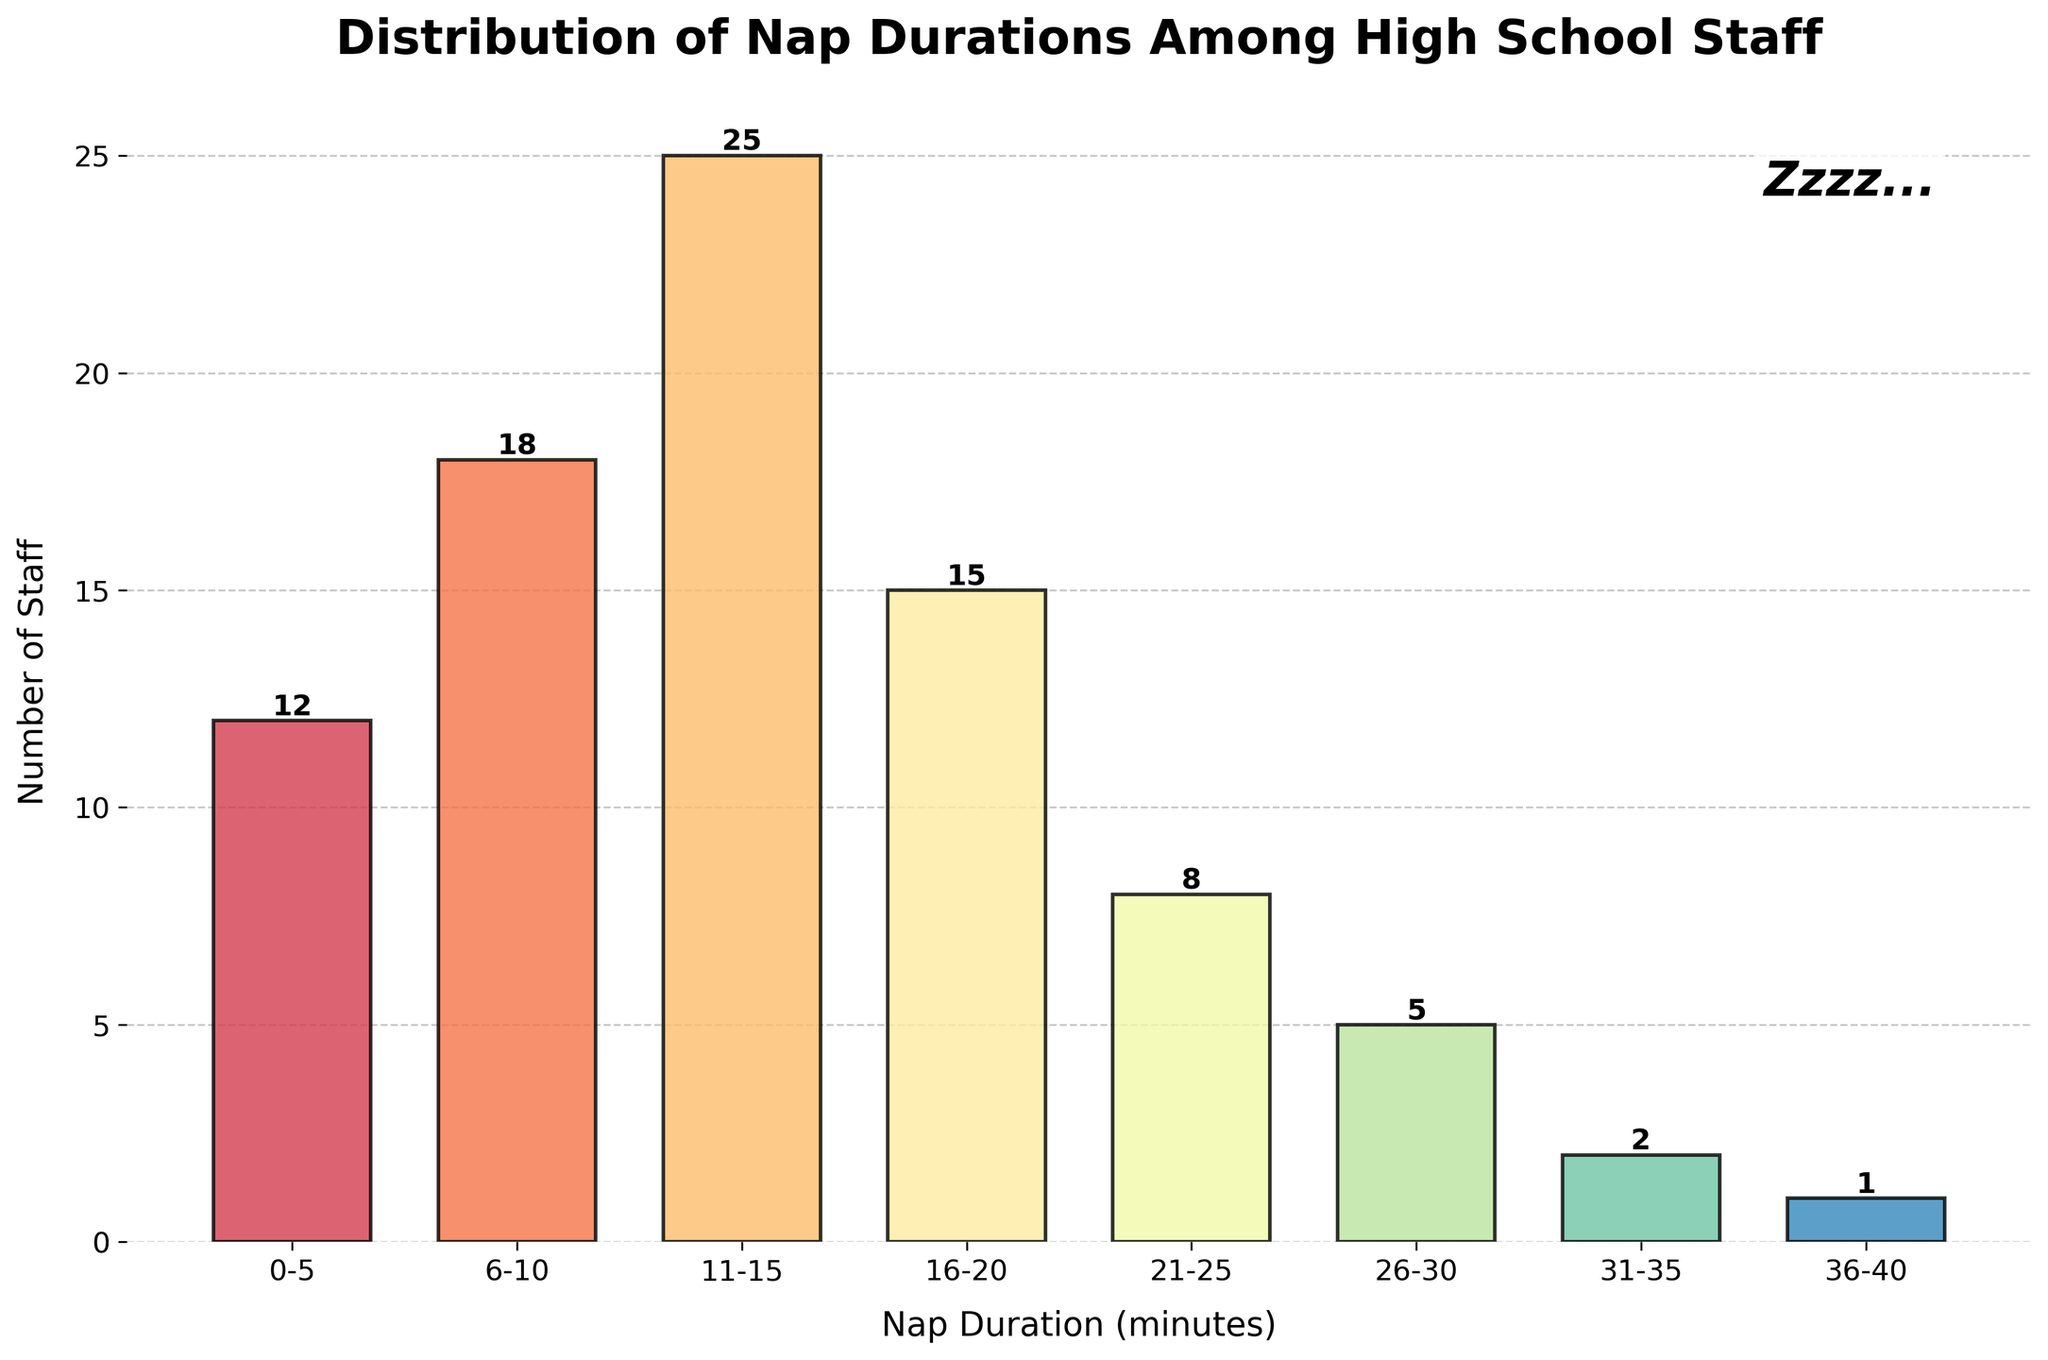How many staff members typically nap for more than 20 minutes? To find the total number of staff napping for more than 20 minutes, sum the counts for the intervals: 21-25 (8), 26-30 (5), 31-35 (2), and 36-40 (1). So, 8 + 5 + 2 + 1 = 16.
Answer: 16 What is the most common nap duration among the staff? The bar with the highest count represents the most common nap duration. The interval 11-15 minutes has the highest count at 25 staff members.
Answer: 11-15 minutes Which nap duration interval has the fewest staff members? Identify the shortest bar in the chart, which represents the interval 36-40 minutes with only 1 staff member.
Answer: 36-40 minutes How many more staff nap for 11-15 minutes than for 21-25 minutes? Compare the counts of the two intervals: 11-15 minutes (25) and 21-25 minutes (8). The difference is 25 - 8 = 17.
Answer: 17 What is the total number of staff members who take naps during lunch breaks? Sum the counts for all intervals: 12 + 18 + 25 + 15 + 8 + 5 + 2 + 1 = 86.
Answer: 86 How many staff members nap for up to 10 minutes? Sum the counts for the intervals: 0-5 (12) and 6-10 (18). So, 12 + 18 = 30.
Answer: 30 Are there more staff members who nap for less than 15 minutes or more than 15 minutes? Sum the counts for staff napping less than 15 minutes: 0-5 (12) + 6-10 (18) + 11-15 (25) = 55. Sum the counts for staff napping more than 15 minutes: 16-20 (15) + 21-25 (8) + 26-30 (5) + 31-35 (2) + 36-40 (1) = 31. Since 55 > 31, there are more who nap for less than 15 minutes.
Answer: Less than 15 minutes What percentage of staff nap for 15 minutes or less? First, find the total number of staff: 86. Then, sum the staff counts for durations 0-5 (12), 6-10 (18), and 11-15 (25), which gives 55. Calculate the percentage: (55 / 86) * 100 ≈ 63.95%.
Answer: Approximately 63.95% Describe the color used for the bar representing the 16-20 minutes nap duration. The colors of the bars transition smoothly across a spectrum. The bar for 16-20 minutes is in the middle of the dataset, so it should have a medium tone from the given color scheme, likely a teal or light green.
Answer: Teal or light green 